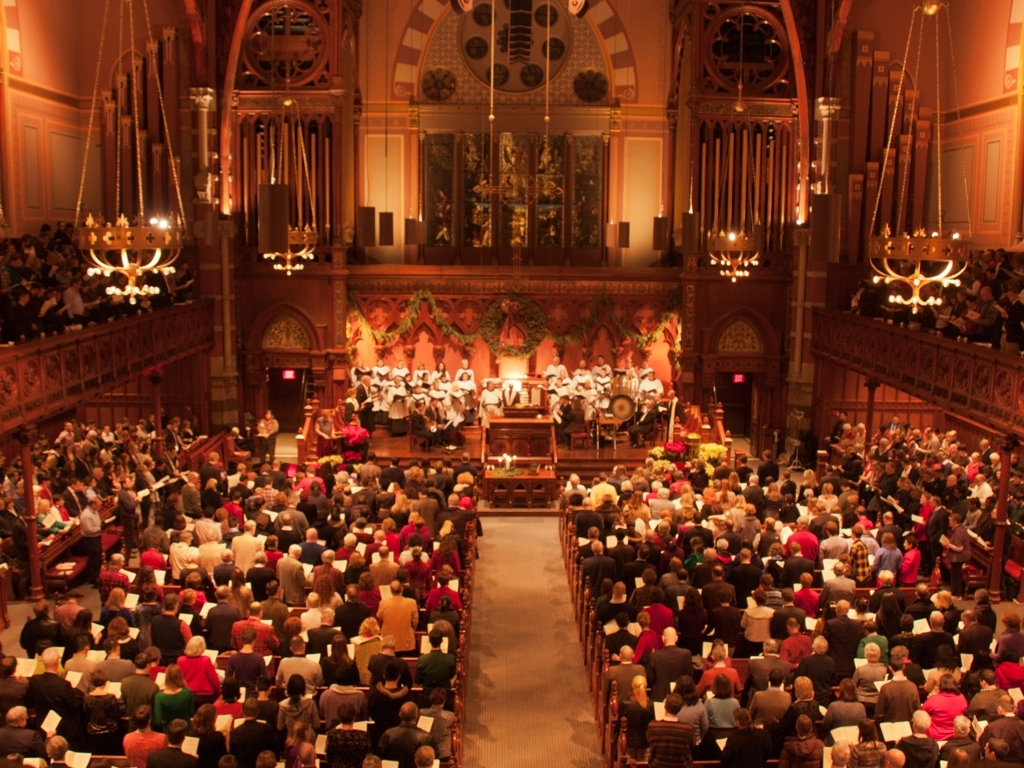Can you describe the event taking place? The image showcases an indoor gathering, likely a concert or service, with a choir positioned on the stage and an audience actively participating, perhaps in a sing-along or liturgy. The setting appears to be a grand hall or church, considering the ornate interior and presence of an organ. What can you tell about the architecture of this place? The architecture suggests a historical or traditional venue, possibly Victorian or Gothic revival, characterized by arched windows and an expansive pipe organ facade. The decoration is intricate, with a coffered ceiling and elegant chandeliers, implying that this is a place of importance, designed for large gatherings or ceremonies. 